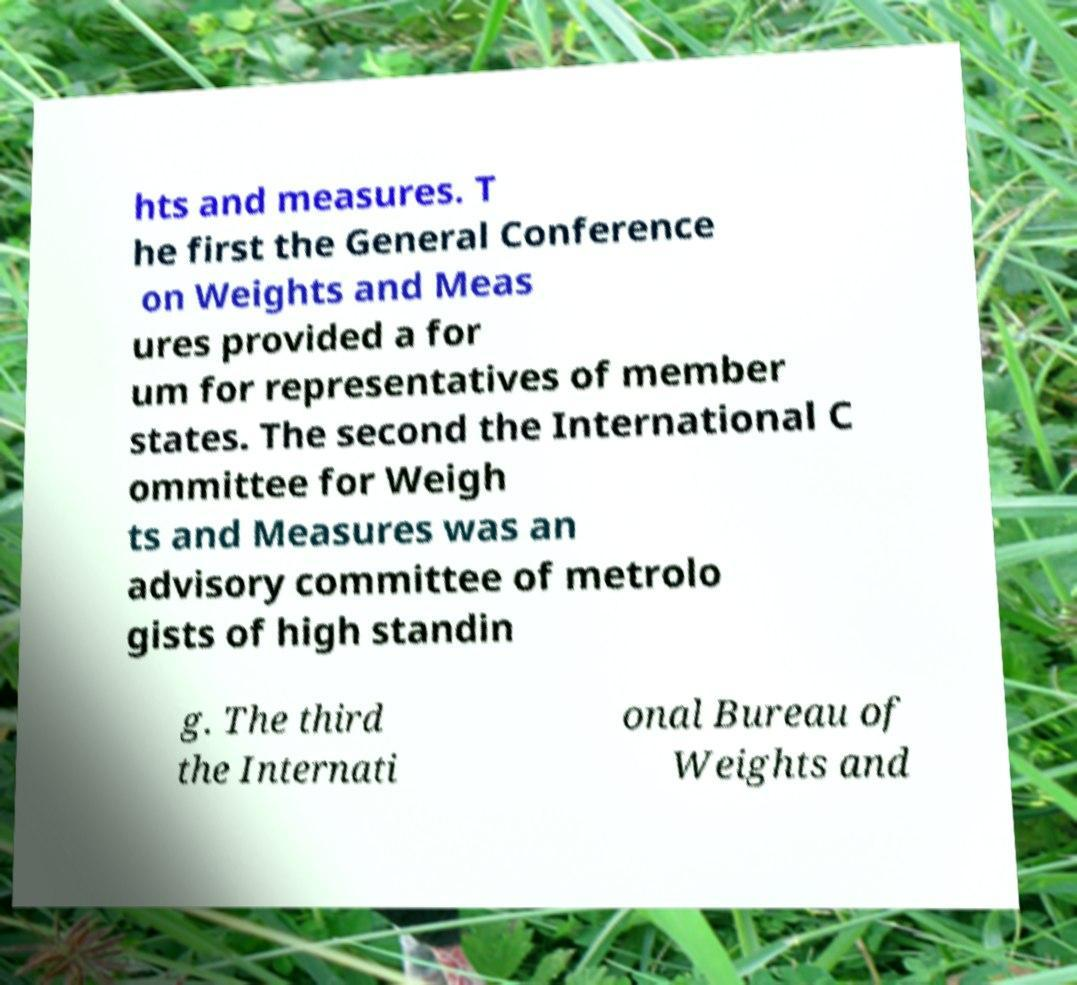Can you accurately transcribe the text from the provided image for me? hts and measures. T he first the General Conference on Weights and Meas ures provided a for um for representatives of member states. The second the International C ommittee for Weigh ts and Measures was an advisory committee of metrolo gists of high standin g. The third the Internati onal Bureau of Weights and 